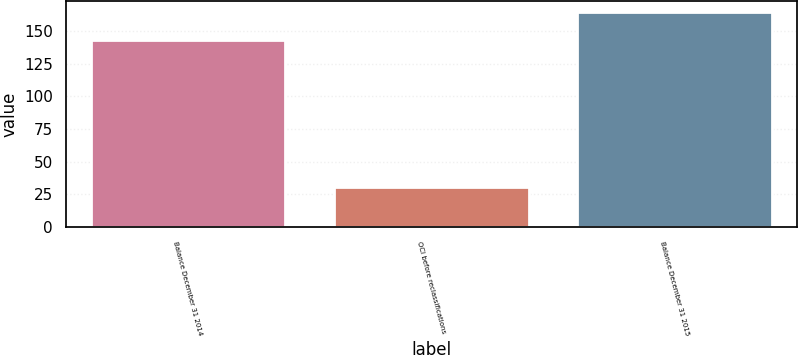Convert chart. <chart><loc_0><loc_0><loc_500><loc_500><bar_chart><fcel>Balance December 31 2014<fcel>OCI before reclassifications<fcel>Balance December 31 2015<nl><fcel>143.4<fcel>30.6<fcel>164.8<nl></chart> 